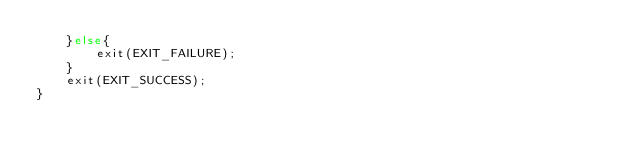Convert code to text. <code><loc_0><loc_0><loc_500><loc_500><_C_>	}else{
		exit(EXIT_FAILURE);
	}
	exit(EXIT_SUCCESS);
}

</code> 